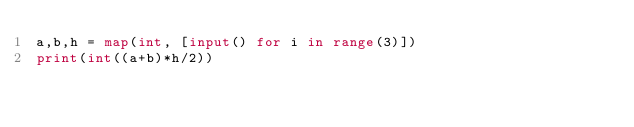<code> <loc_0><loc_0><loc_500><loc_500><_Python_>a,b,h = map(int, [input() for i in range(3)])
print(int((a+b)*h/2))</code> 